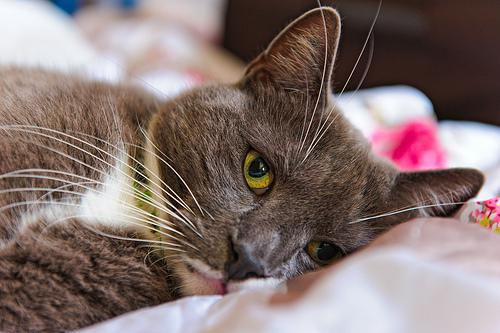Question: why is the cat on the bed?
Choices:
A. It's sleeping.
B. It's playing with a ball of yarn.
C. It's playing with it's owner.
D. It's laying down.
Answer with the letter. Answer: D Question: how many cats?
Choices:
A. 1.
B. 2.
C. 3.
D. 4.
Answer with the letter. Answer: A Question: who has a green collar?
Choices:
A. The cat.
B. The dog.
C. The elephant.
D. The goat.
Answer with the letter. Answer: A 